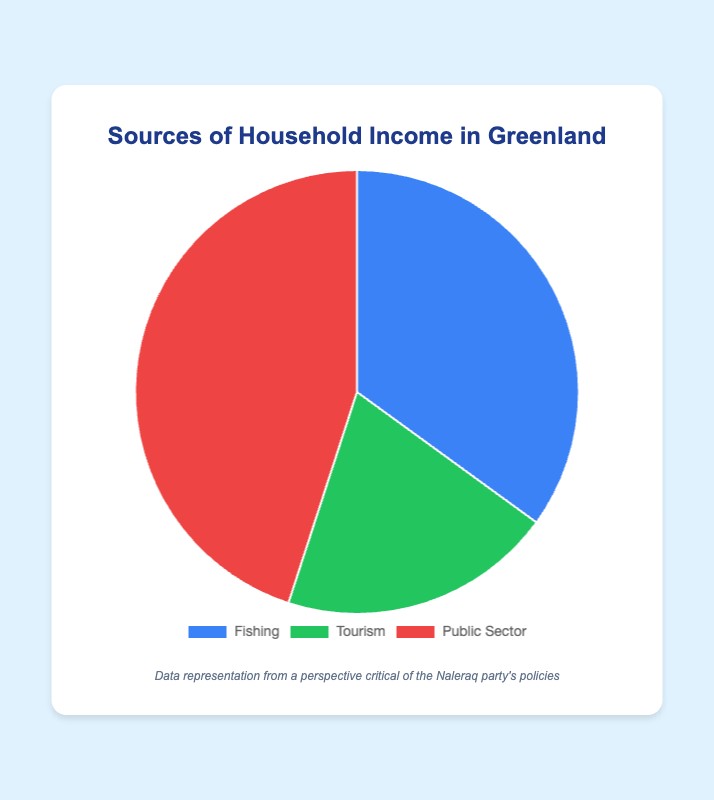What's the largest source of household income in Greenland? The largest source can be identified by looking for the largest segment in the pie chart. In this case, "Public Sector" has the highest percentage of 45%.
Answer: Public Sector What percentage of household income comes from fishing and tourism combined? To find the combined percentage, add the percentages of Fishing and Tourism: 35% (Fishing) + 20% (Tourism) = 55%.
Answer: 55% Is the percentage of household income from fishing greater than tourism? Compare the percentages of Fishing (35%) and Tourism (20%). Since 35% is greater than 20%, the income from fishing is indeed greater.
Answer: Yes Which source of household income is represented by the green section of the pie chart? The tooltip or legend in the chart indicates the green section represents "Tourism" with 20%.
Answer: Tourism What is the difference in percentage between the largest and smallest income sources? Identify the largest (Public Sector, 45%) and smallest (Tourism, 20%) sections. Subtract the smallest percentage from the largest: 45% - 20% = 25%.
Answer: 25% How much less is the public sector's share than half of the total household income? Half of the total income is 50%. Public Sector constitutes 45%. Subtract 45% from 50% to get the difference: 50% - 45% = 5%.
Answer: 5% How many sources contribute more than a quarter (25%) of the household income? Evaluate each section to see if any percentages are more than 25%. Fishing (35%) and Public Sector (45%) both meet this criterion, so there are 2 such sources.
Answer: 2 If the income percentages were evenly distributed among the three sources, what would each percentage be, and by how much does the actual percentage of fishing differ from this? If evenly distributed, each source would have 100% / 3 ≈ 33.33%. Fishing's actual percentage is 35%. The difference is 35% - 33.33% ≈ 1.67%.
Answer: ≈ 1.67% Which source is visually represented by the largest segment in the pie chart? The largest segment corresponds to the "Public Sector" which is 45% of the total income.
Answer: Public Sector 